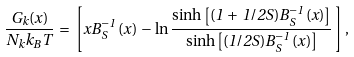<formula> <loc_0><loc_0><loc_500><loc_500>\frac { G _ { k } ( x ) } { N _ { k } k _ { B } T } \, = \, \left [ x B _ { S } ^ { - 1 } \, ( x ) \, - \, \ln \frac { \sinh \left [ ( 1 \, + \, 1 / 2 S ) B _ { S } ^ { - 1 } \, ( x ) \right ] } { \sinh \left [ ( 1 / 2 S ) B _ { S } ^ { - 1 } \, ( x ) \right ] } \, \right ] ,</formula> 